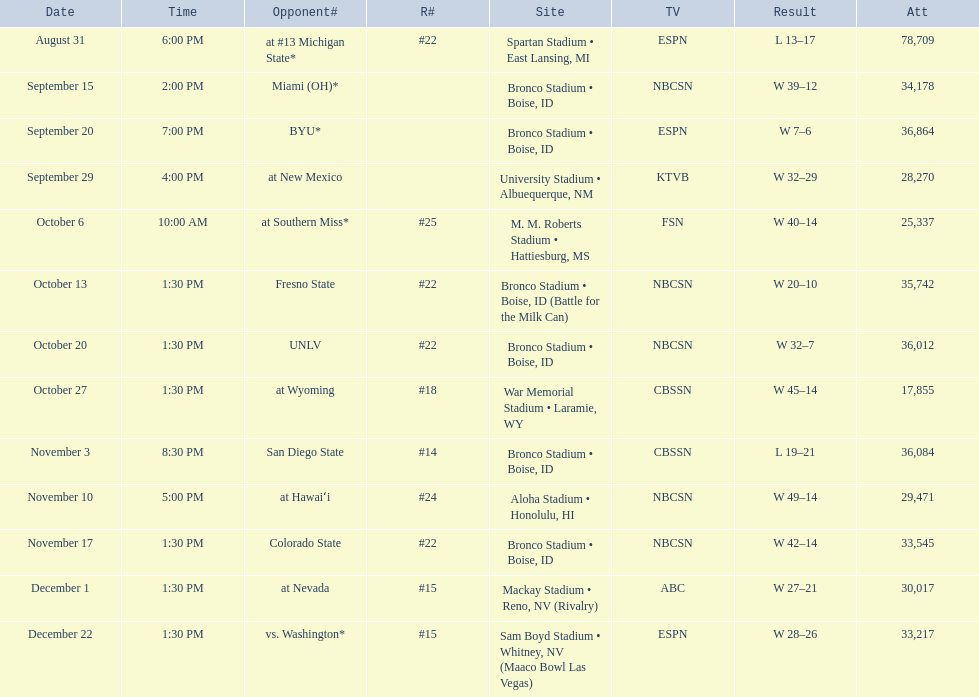What was the team's listed rankings for the season? #22, , , , #25, #22, #22, #18, #14, #24, #22, #15, #15. Parse the table in full. {'header': ['Date', 'Time', 'Opponent#', 'R#', 'Site', 'TV', 'Result', 'Att'], 'rows': [['August 31', '6:00 PM', 'at\xa0#13\xa0Michigan State*', '#22', 'Spartan Stadium • East Lansing, MI', 'ESPN', 'L\xa013–17', '78,709'], ['September 15', '2:00 PM', 'Miami (OH)*', '', 'Bronco Stadium • Boise, ID', 'NBCSN', 'W\xa039–12', '34,178'], ['September 20', '7:00 PM', 'BYU*', '', 'Bronco Stadium • Boise, ID', 'ESPN', 'W\xa07–6', '36,864'], ['September 29', '4:00 PM', 'at\xa0New Mexico', '', 'University Stadium • Albuequerque, NM', 'KTVB', 'W\xa032–29', '28,270'], ['October 6', '10:00 AM', 'at\xa0Southern Miss*', '#25', 'M. M. Roberts Stadium • Hattiesburg, MS', 'FSN', 'W\xa040–14', '25,337'], ['October 13', '1:30 PM', 'Fresno State', '#22', 'Bronco Stadium • Boise, ID (Battle for the Milk Can)', 'NBCSN', 'W\xa020–10', '35,742'], ['October 20', '1:30 PM', 'UNLV', '#22', 'Bronco Stadium • Boise, ID', 'NBCSN', 'W\xa032–7', '36,012'], ['October 27', '1:30 PM', 'at\xa0Wyoming', '#18', 'War Memorial Stadium • Laramie, WY', 'CBSSN', 'W\xa045–14', '17,855'], ['November 3', '8:30 PM', 'San Diego State', '#14', 'Bronco Stadium • Boise, ID', 'CBSSN', 'L\xa019–21', '36,084'], ['November 10', '5:00 PM', 'at\xa0Hawaiʻi', '#24', 'Aloha Stadium • Honolulu, HI', 'NBCSN', 'W\xa049–14', '29,471'], ['November 17', '1:30 PM', 'Colorado State', '#22', 'Bronco Stadium • Boise, ID', 'NBCSN', 'W\xa042–14', '33,545'], ['December 1', '1:30 PM', 'at\xa0Nevada', '#15', 'Mackay Stadium • Reno, NV (Rivalry)', 'ABC', 'W\xa027–21', '30,017'], ['December 22', '1:30 PM', 'vs.\xa0Washington*', '#15', 'Sam Boyd Stadium • Whitney, NV (Maaco Bowl Las Vegas)', 'ESPN', 'W\xa028–26', '33,217']]} Which of these ranks is the best? #14. 